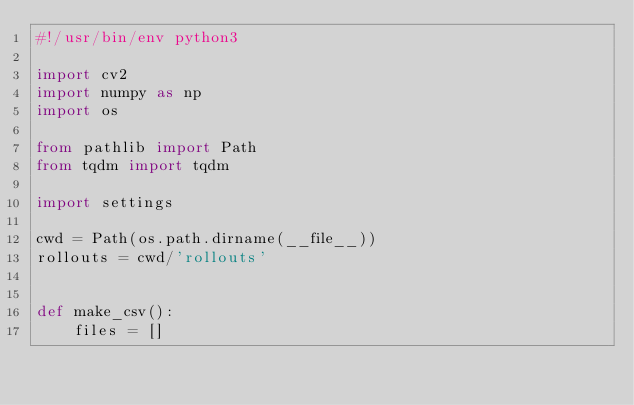<code> <loc_0><loc_0><loc_500><loc_500><_Python_>#!/usr/bin/env python3

import cv2
import numpy as np
import os

from pathlib import Path
from tqdm import tqdm

import settings

cwd = Path(os.path.dirname(__file__))
rollouts = cwd/'rollouts'


def make_csv():
    files = []</code> 